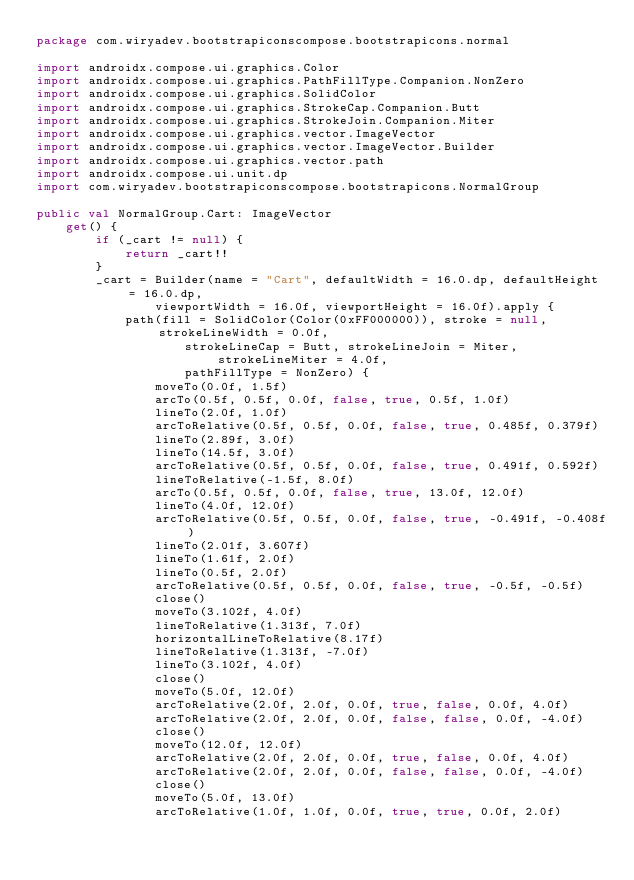<code> <loc_0><loc_0><loc_500><loc_500><_Kotlin_>package com.wiryadev.bootstrapiconscompose.bootstrapicons.normal

import androidx.compose.ui.graphics.Color
import androidx.compose.ui.graphics.PathFillType.Companion.NonZero
import androidx.compose.ui.graphics.SolidColor
import androidx.compose.ui.graphics.StrokeCap.Companion.Butt
import androidx.compose.ui.graphics.StrokeJoin.Companion.Miter
import androidx.compose.ui.graphics.vector.ImageVector
import androidx.compose.ui.graphics.vector.ImageVector.Builder
import androidx.compose.ui.graphics.vector.path
import androidx.compose.ui.unit.dp
import com.wiryadev.bootstrapiconscompose.bootstrapicons.NormalGroup

public val NormalGroup.Cart: ImageVector
    get() {
        if (_cart != null) {
            return _cart!!
        }
        _cart = Builder(name = "Cart", defaultWidth = 16.0.dp, defaultHeight = 16.0.dp,
                viewportWidth = 16.0f, viewportHeight = 16.0f).apply {
            path(fill = SolidColor(Color(0xFF000000)), stroke = null, strokeLineWidth = 0.0f,
                    strokeLineCap = Butt, strokeLineJoin = Miter, strokeLineMiter = 4.0f,
                    pathFillType = NonZero) {
                moveTo(0.0f, 1.5f)
                arcTo(0.5f, 0.5f, 0.0f, false, true, 0.5f, 1.0f)
                lineTo(2.0f, 1.0f)
                arcToRelative(0.5f, 0.5f, 0.0f, false, true, 0.485f, 0.379f)
                lineTo(2.89f, 3.0f)
                lineTo(14.5f, 3.0f)
                arcToRelative(0.5f, 0.5f, 0.0f, false, true, 0.491f, 0.592f)
                lineToRelative(-1.5f, 8.0f)
                arcTo(0.5f, 0.5f, 0.0f, false, true, 13.0f, 12.0f)
                lineTo(4.0f, 12.0f)
                arcToRelative(0.5f, 0.5f, 0.0f, false, true, -0.491f, -0.408f)
                lineTo(2.01f, 3.607f)
                lineTo(1.61f, 2.0f)
                lineTo(0.5f, 2.0f)
                arcToRelative(0.5f, 0.5f, 0.0f, false, true, -0.5f, -0.5f)
                close()
                moveTo(3.102f, 4.0f)
                lineToRelative(1.313f, 7.0f)
                horizontalLineToRelative(8.17f)
                lineToRelative(1.313f, -7.0f)
                lineTo(3.102f, 4.0f)
                close()
                moveTo(5.0f, 12.0f)
                arcToRelative(2.0f, 2.0f, 0.0f, true, false, 0.0f, 4.0f)
                arcToRelative(2.0f, 2.0f, 0.0f, false, false, 0.0f, -4.0f)
                close()
                moveTo(12.0f, 12.0f)
                arcToRelative(2.0f, 2.0f, 0.0f, true, false, 0.0f, 4.0f)
                arcToRelative(2.0f, 2.0f, 0.0f, false, false, 0.0f, -4.0f)
                close()
                moveTo(5.0f, 13.0f)
                arcToRelative(1.0f, 1.0f, 0.0f, true, true, 0.0f, 2.0f)</code> 